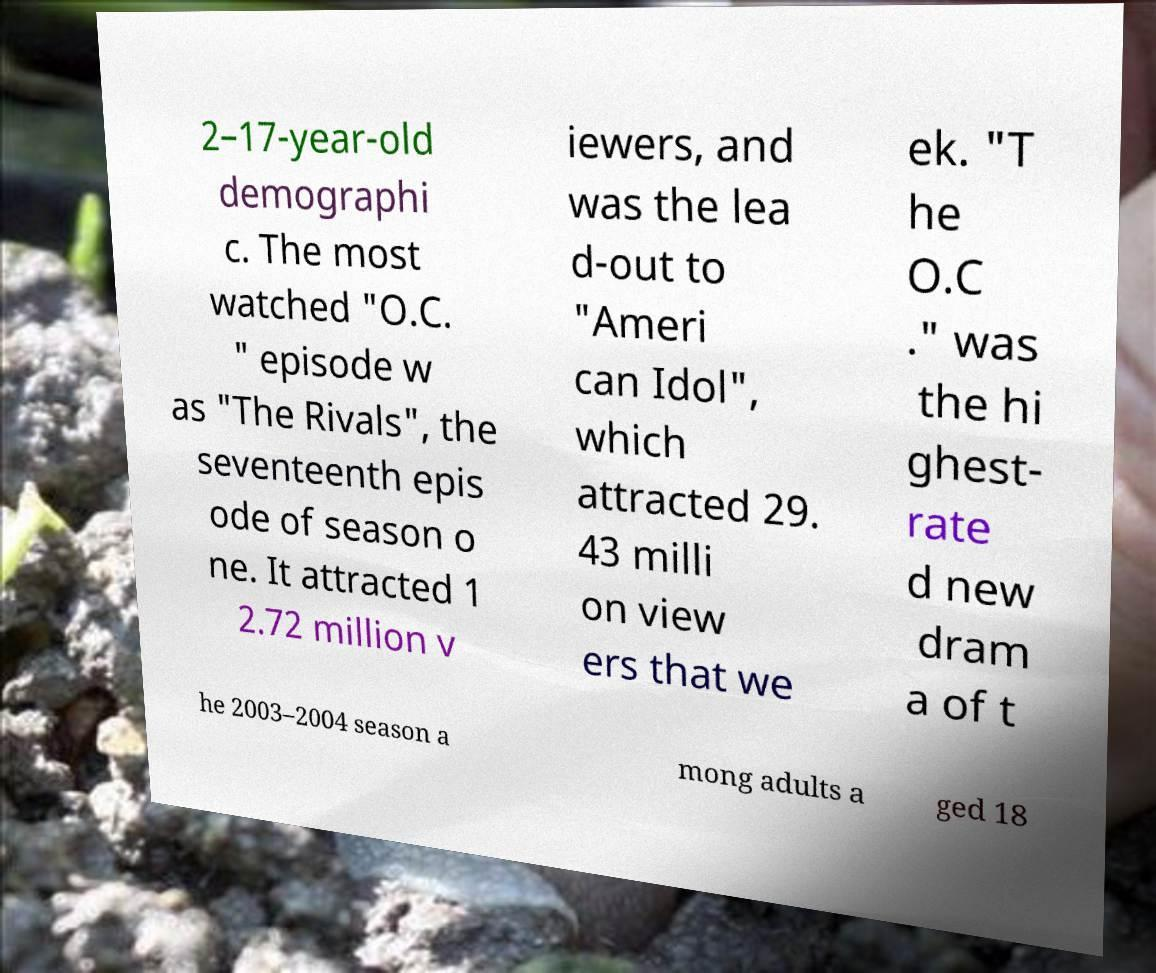I need the written content from this picture converted into text. Can you do that? 2–17-year-old demographi c. The most watched "O.C. " episode w as "The Rivals", the seventeenth epis ode of season o ne. It attracted 1 2.72 million v iewers, and was the lea d-out to "Ameri can Idol", which attracted 29. 43 milli on view ers that we ek. "T he O.C ." was the hi ghest- rate d new dram a of t he 2003–2004 season a mong adults a ged 18 